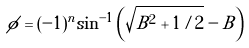Convert formula to latex. <formula><loc_0><loc_0><loc_500><loc_500>\phi = ( - 1 ) ^ { n } \sin ^ { - 1 } \left ( \sqrt { B ^ { 2 } + 1 / 2 } - B \right )</formula> 